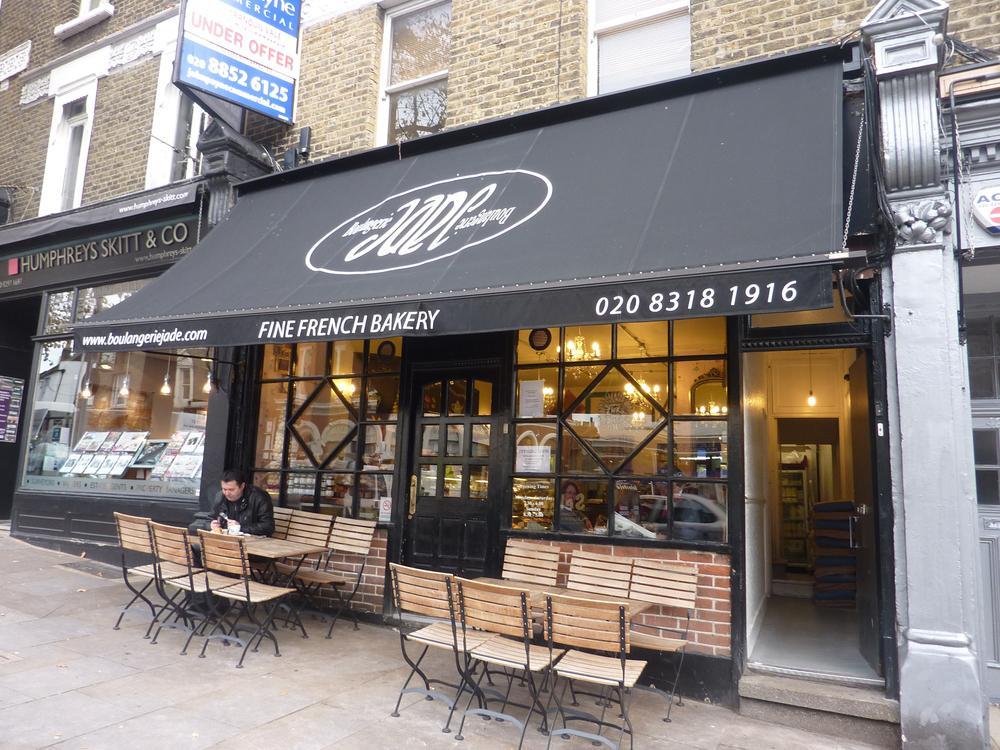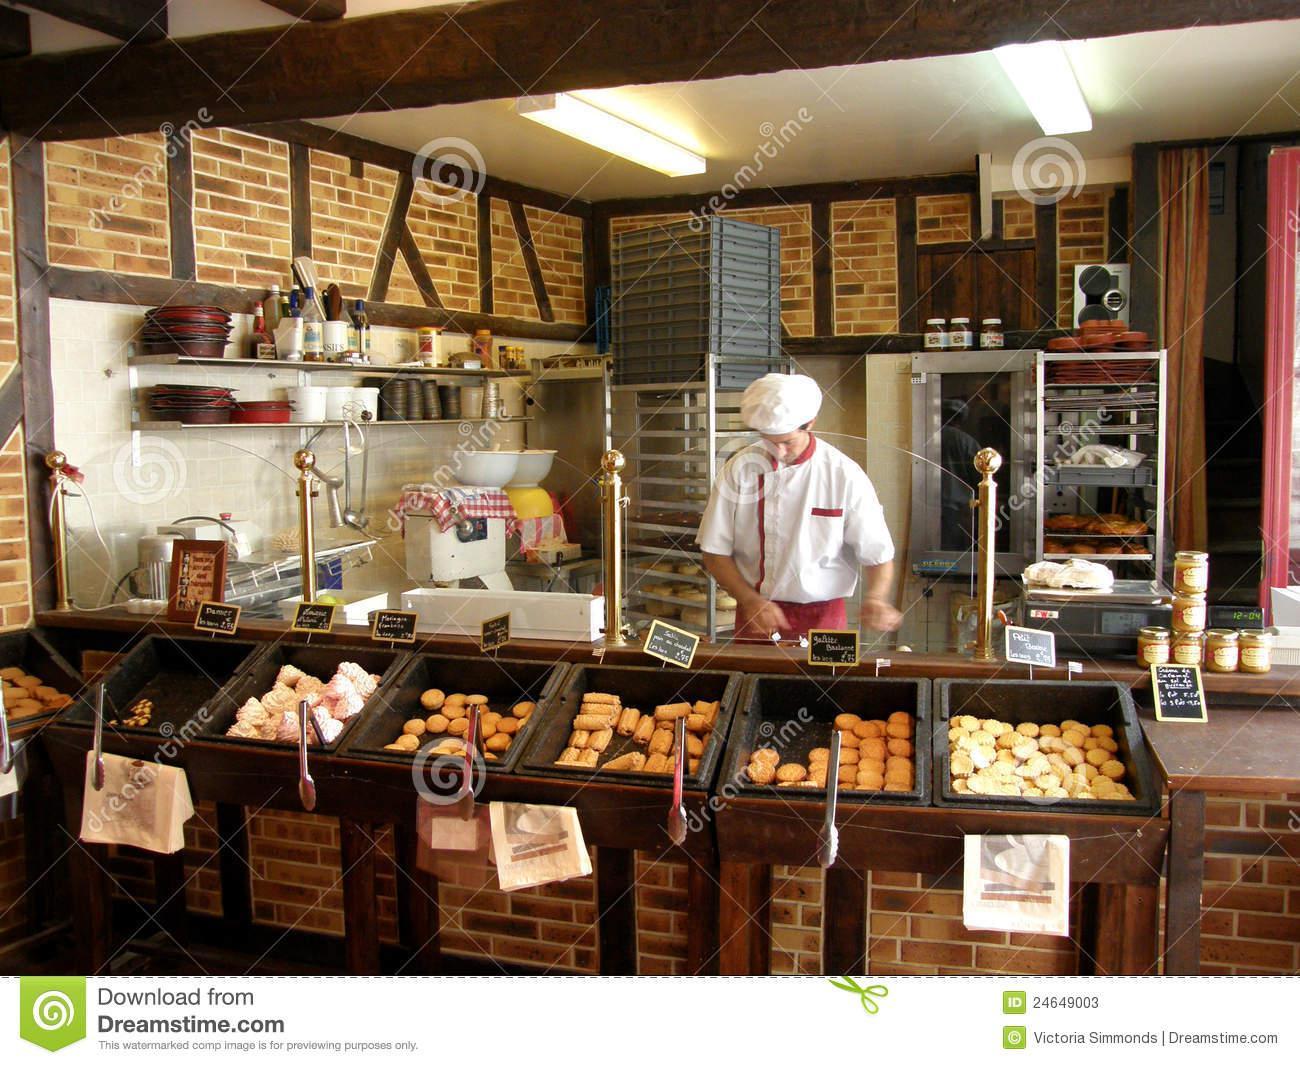The first image is the image on the left, the second image is the image on the right. Given the left and right images, does the statement "People stand at the counter waiting for service in the image on the left." hold true? Answer yes or no. No. The first image is the image on the left, the second image is the image on the right. Considering the images on both sides, is "At least one female with back to the camera is at a service counter in one image." valid? Answer yes or no. No. 